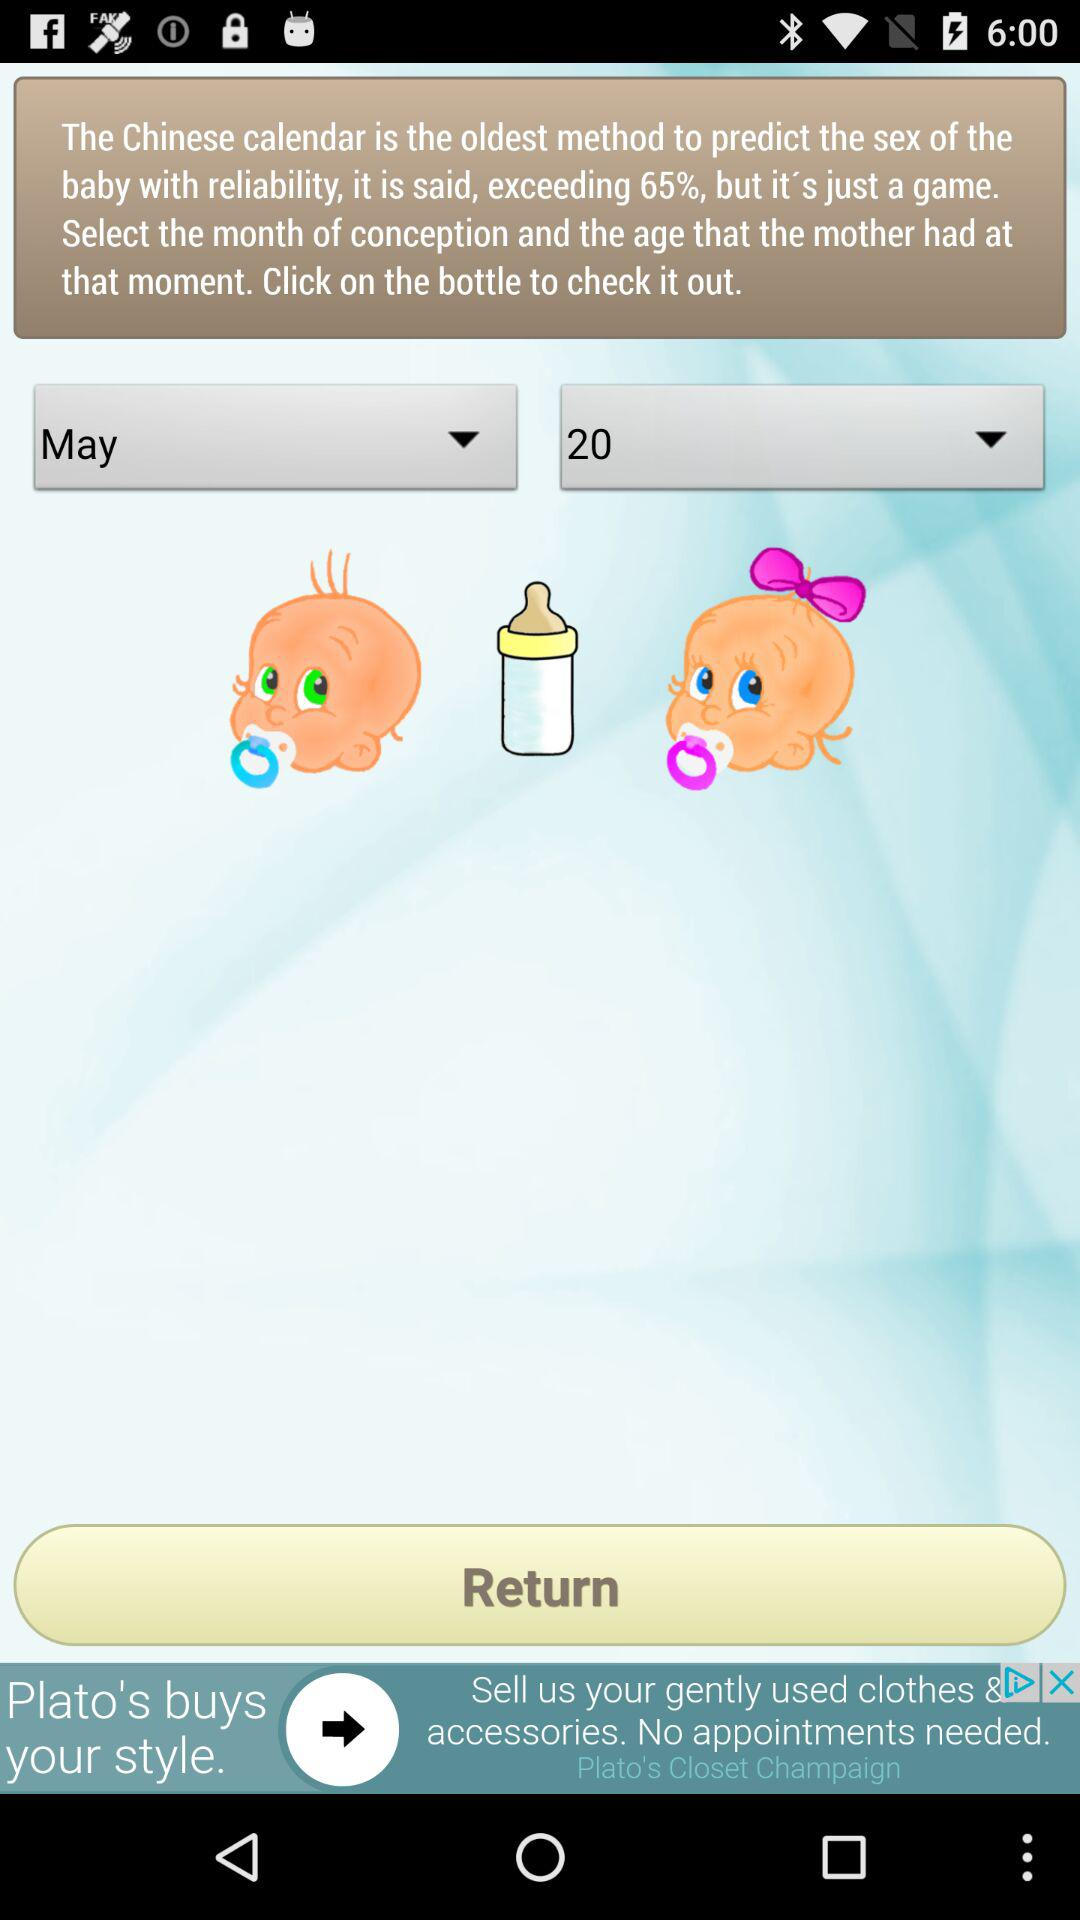Is the baby a boy or a girl?
When the provided information is insufficient, respond with <no answer>. <no answer> 